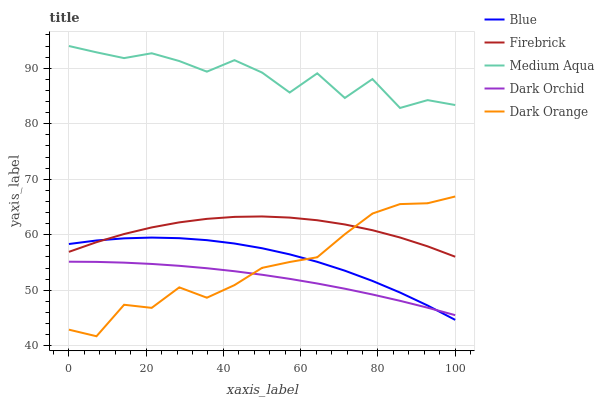Does Dark Orchid have the minimum area under the curve?
Answer yes or no. Yes. Does Medium Aqua have the maximum area under the curve?
Answer yes or no. Yes. Does Dark Orange have the minimum area under the curve?
Answer yes or no. No. Does Dark Orange have the maximum area under the curve?
Answer yes or no. No. Is Dark Orchid the smoothest?
Answer yes or no. Yes. Is Medium Aqua the roughest?
Answer yes or no. Yes. Is Dark Orange the smoothest?
Answer yes or no. No. Is Dark Orange the roughest?
Answer yes or no. No. Does Dark Orange have the lowest value?
Answer yes or no. Yes. Does Firebrick have the lowest value?
Answer yes or no. No. Does Medium Aqua have the highest value?
Answer yes or no. Yes. Does Dark Orange have the highest value?
Answer yes or no. No. Is Dark Orange less than Medium Aqua?
Answer yes or no. Yes. Is Firebrick greater than Dark Orchid?
Answer yes or no. Yes. Does Firebrick intersect Blue?
Answer yes or no. Yes. Is Firebrick less than Blue?
Answer yes or no. No. Is Firebrick greater than Blue?
Answer yes or no. No. Does Dark Orange intersect Medium Aqua?
Answer yes or no. No. 